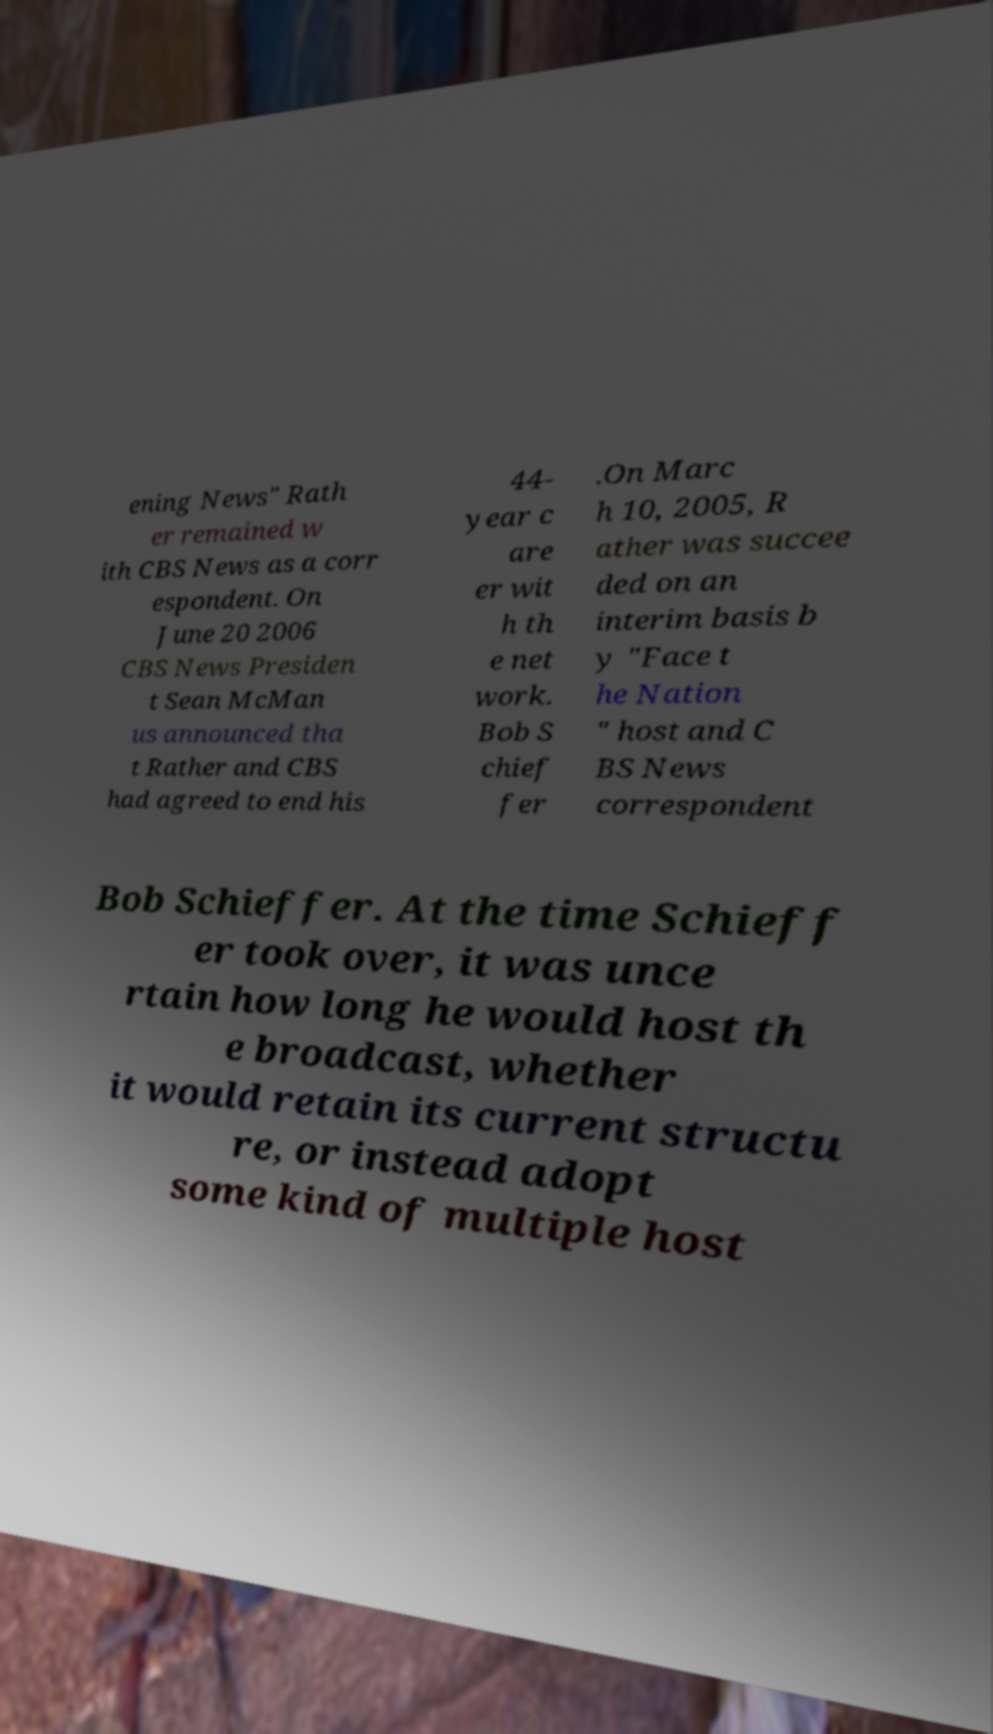Can you read and provide the text displayed in the image?This photo seems to have some interesting text. Can you extract and type it out for me? ening News" Rath er remained w ith CBS News as a corr espondent. On June 20 2006 CBS News Presiden t Sean McMan us announced tha t Rather and CBS had agreed to end his 44- year c are er wit h th e net work. Bob S chief fer .On Marc h 10, 2005, R ather was succee ded on an interim basis b y "Face t he Nation " host and C BS News correspondent Bob Schieffer. At the time Schieff er took over, it was unce rtain how long he would host th e broadcast, whether it would retain its current structu re, or instead adopt some kind of multiple host 